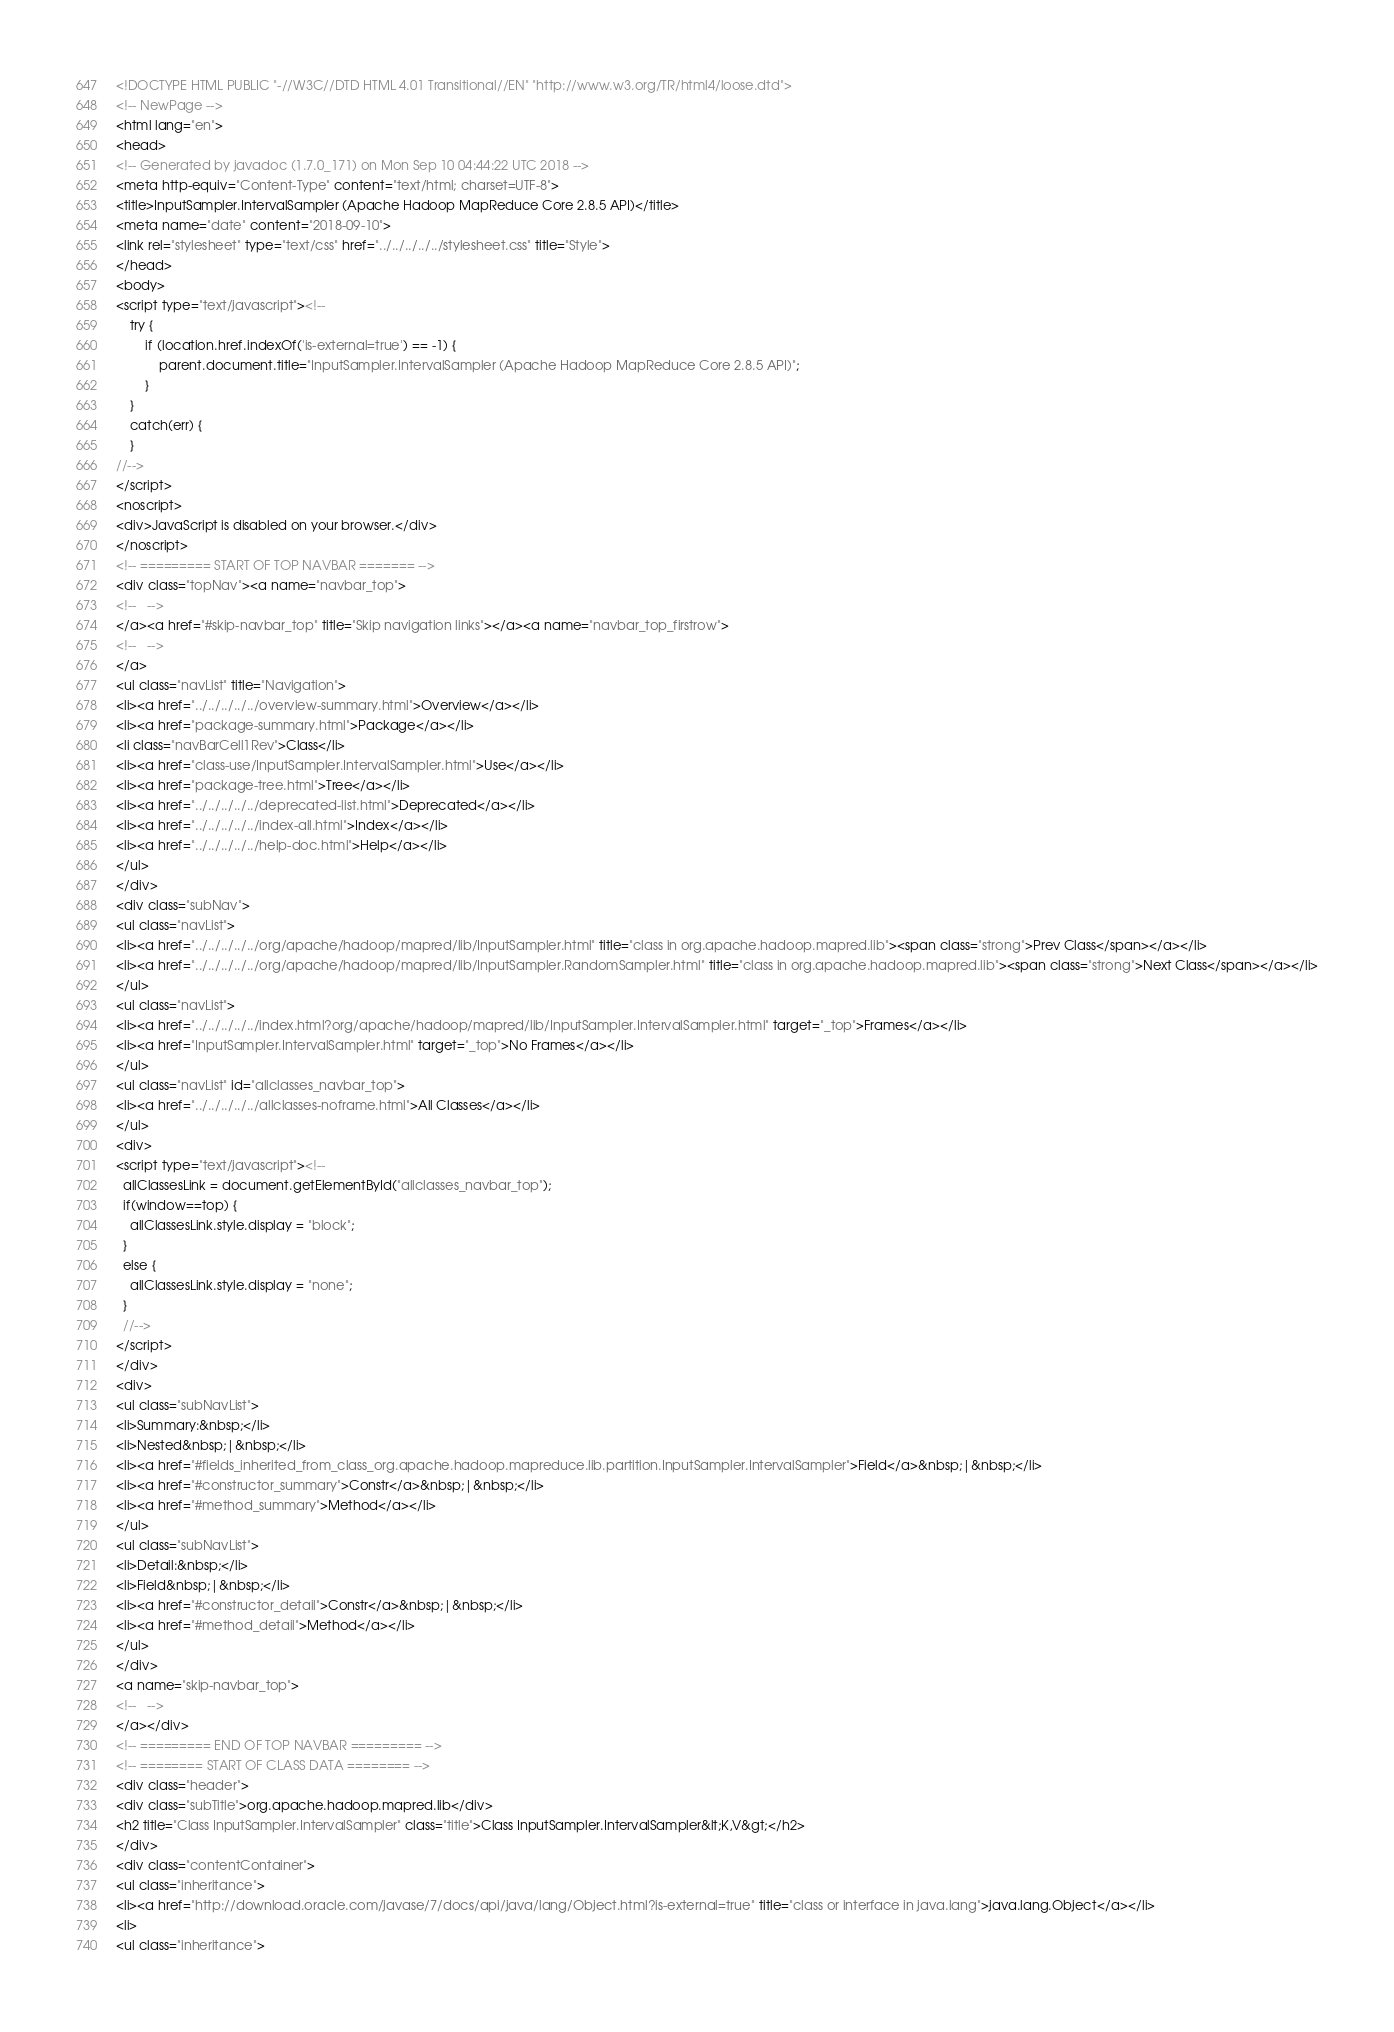Convert code to text. <code><loc_0><loc_0><loc_500><loc_500><_HTML_><!DOCTYPE HTML PUBLIC "-//W3C//DTD HTML 4.01 Transitional//EN" "http://www.w3.org/TR/html4/loose.dtd">
<!-- NewPage -->
<html lang="en">
<head>
<!-- Generated by javadoc (1.7.0_171) on Mon Sep 10 04:44:22 UTC 2018 -->
<meta http-equiv="Content-Type" content="text/html; charset=UTF-8">
<title>InputSampler.IntervalSampler (Apache Hadoop MapReduce Core 2.8.5 API)</title>
<meta name="date" content="2018-09-10">
<link rel="stylesheet" type="text/css" href="../../../../../stylesheet.css" title="Style">
</head>
<body>
<script type="text/javascript"><!--
    try {
        if (location.href.indexOf('is-external=true') == -1) {
            parent.document.title="InputSampler.IntervalSampler (Apache Hadoop MapReduce Core 2.8.5 API)";
        }
    }
    catch(err) {
    }
//-->
</script>
<noscript>
<div>JavaScript is disabled on your browser.</div>
</noscript>
<!-- ========= START OF TOP NAVBAR ======= -->
<div class="topNav"><a name="navbar_top">
<!--   -->
</a><a href="#skip-navbar_top" title="Skip navigation links"></a><a name="navbar_top_firstrow">
<!--   -->
</a>
<ul class="navList" title="Navigation">
<li><a href="../../../../../overview-summary.html">Overview</a></li>
<li><a href="package-summary.html">Package</a></li>
<li class="navBarCell1Rev">Class</li>
<li><a href="class-use/InputSampler.IntervalSampler.html">Use</a></li>
<li><a href="package-tree.html">Tree</a></li>
<li><a href="../../../../../deprecated-list.html">Deprecated</a></li>
<li><a href="../../../../../index-all.html">Index</a></li>
<li><a href="../../../../../help-doc.html">Help</a></li>
</ul>
</div>
<div class="subNav">
<ul class="navList">
<li><a href="../../../../../org/apache/hadoop/mapred/lib/InputSampler.html" title="class in org.apache.hadoop.mapred.lib"><span class="strong">Prev Class</span></a></li>
<li><a href="../../../../../org/apache/hadoop/mapred/lib/InputSampler.RandomSampler.html" title="class in org.apache.hadoop.mapred.lib"><span class="strong">Next Class</span></a></li>
</ul>
<ul class="navList">
<li><a href="../../../../../index.html?org/apache/hadoop/mapred/lib/InputSampler.IntervalSampler.html" target="_top">Frames</a></li>
<li><a href="InputSampler.IntervalSampler.html" target="_top">No Frames</a></li>
</ul>
<ul class="navList" id="allclasses_navbar_top">
<li><a href="../../../../../allclasses-noframe.html">All Classes</a></li>
</ul>
<div>
<script type="text/javascript"><!--
  allClassesLink = document.getElementById("allclasses_navbar_top");
  if(window==top) {
    allClassesLink.style.display = "block";
  }
  else {
    allClassesLink.style.display = "none";
  }
  //-->
</script>
</div>
<div>
<ul class="subNavList">
<li>Summary:&nbsp;</li>
<li>Nested&nbsp;|&nbsp;</li>
<li><a href="#fields_inherited_from_class_org.apache.hadoop.mapreduce.lib.partition.InputSampler.IntervalSampler">Field</a>&nbsp;|&nbsp;</li>
<li><a href="#constructor_summary">Constr</a>&nbsp;|&nbsp;</li>
<li><a href="#method_summary">Method</a></li>
</ul>
<ul class="subNavList">
<li>Detail:&nbsp;</li>
<li>Field&nbsp;|&nbsp;</li>
<li><a href="#constructor_detail">Constr</a>&nbsp;|&nbsp;</li>
<li><a href="#method_detail">Method</a></li>
</ul>
</div>
<a name="skip-navbar_top">
<!--   -->
</a></div>
<!-- ========= END OF TOP NAVBAR ========= -->
<!-- ======== START OF CLASS DATA ======== -->
<div class="header">
<div class="subTitle">org.apache.hadoop.mapred.lib</div>
<h2 title="Class InputSampler.IntervalSampler" class="title">Class InputSampler.IntervalSampler&lt;K,V&gt;</h2>
</div>
<div class="contentContainer">
<ul class="inheritance">
<li><a href="http://download.oracle.com/javase/7/docs/api/java/lang/Object.html?is-external=true" title="class or interface in java.lang">java.lang.Object</a></li>
<li>
<ul class="inheritance"></code> 